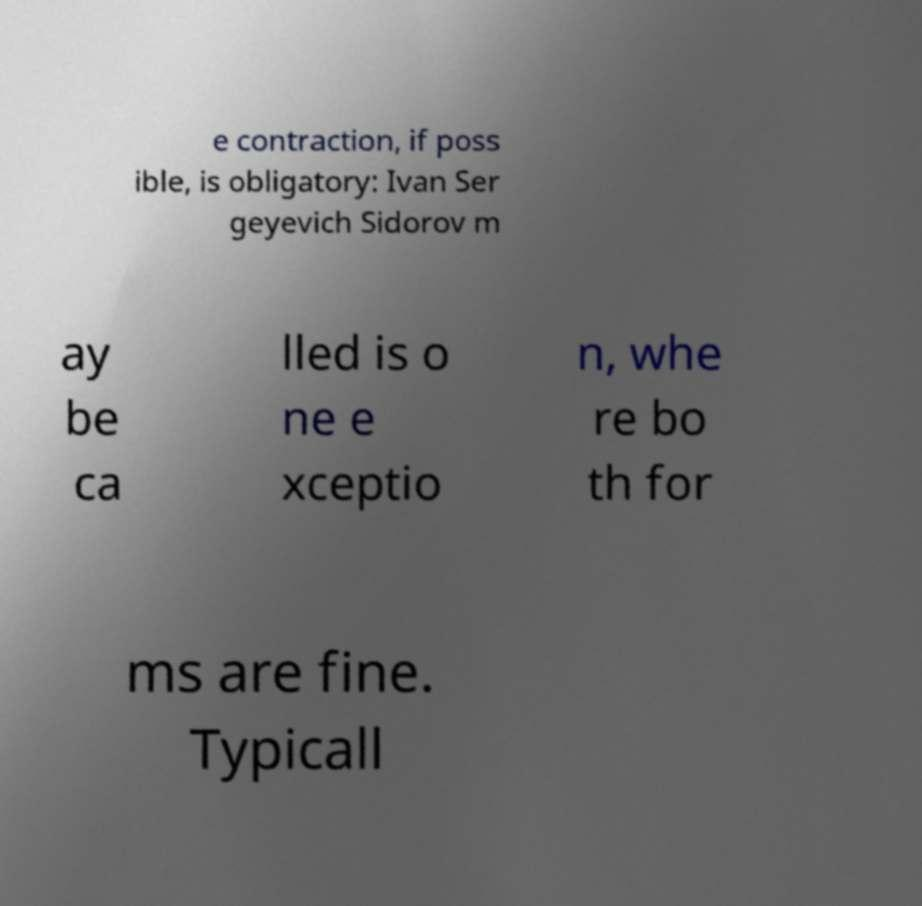Please identify and transcribe the text found in this image. e contraction, if poss ible, is obligatory: Ivan Ser geyevich Sidorov m ay be ca lled is o ne e xceptio n, whe re bo th for ms are fine. Typicall 